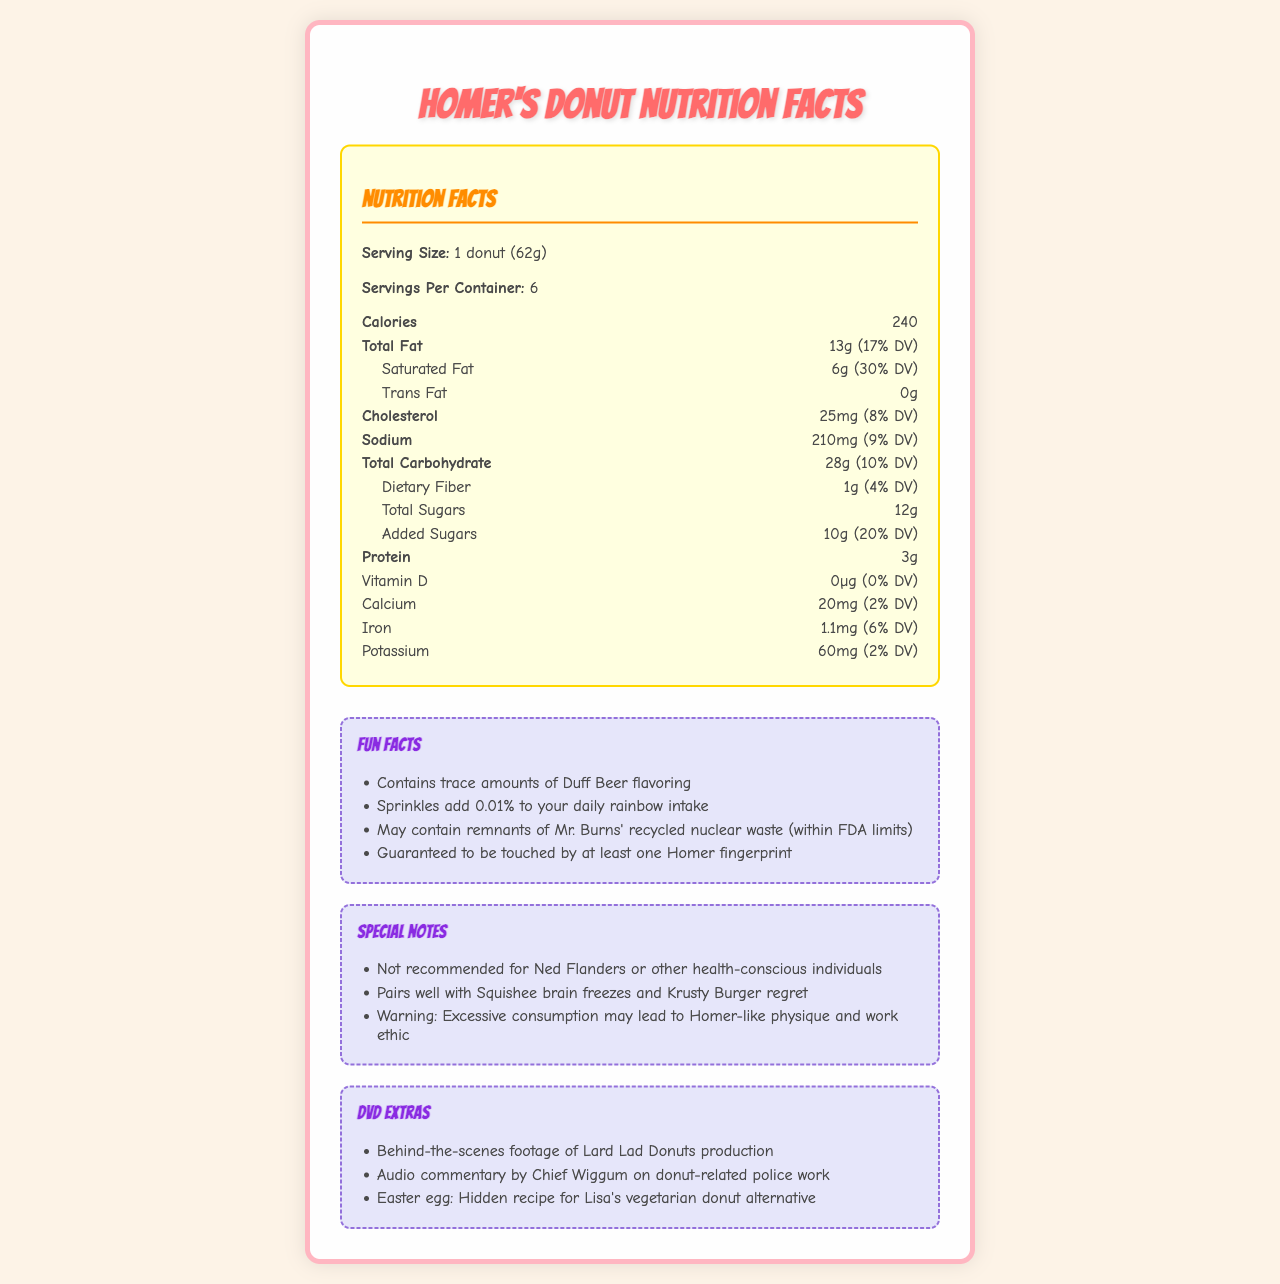what is the daily value percentage of total fat in Homer Simpson's iconic donuts? The 'Total Fat' section mentions that one donut contains 13 grams of fat, which is 17% of the daily value.
Answer: 17% DV what is the daily value percentage of sodium in one donut? The 'Sodium' section lists 210 milligrams of sodium, which is 9% of the daily value.
Answer: 9% DV how much protein is in one serving of the donut? The 'Protein' section states that one donut contains 3 grams of protein.
Answer: 3 grams what are the daily value percentages of Calcium and Iron in one donut? The 'Calcium' section lists 20 milligrams of calcium (2% DV), and the 'Iron' section lists 1.1 milligrams of iron (6% DV).
Answer: Calcium: 2% DV, Iron: 6% DV does the label mention any vitamin D content? The 'Vitamin D' section shows 0 micrograms, which corresponds to 0% of the daily value.
Answer: 0% DV what percentage of your daily value of saturated fat will you consume by eating one donut? The 'Saturated Fat' section lists 6 grams of saturated fat, which is 30% of the daily value.
Answer: 30% DV how much dietary fiber does one donut provide? The 'Dietary Fiber' section lists 1 gram, which is 4% of the daily value.
Answer: 1 gram (4% DV) how many Fun Facts are listed on the label? There are four fun facts listed under the 'Fun Facts' section.
Answer: 4 A single donut contains ___ grams of added sugars. A. 5g B. 10g C. 15g D. 20g The 'Added Sugars' section notes that there are 10 grams of added sugars in one donut.
Answer: B. 10g how many calories are there in one donut? The document lists 240 calories per serving.
Answer: 240 calories what is the daily value percentage of cholesterol in one donut? The 'Cholesterol' section shows 25 milligrams of cholesterol, which is 8% of the daily value.
Answer: 8% DV which of these nutrients is not present in significant amounts in the donuts? A. Vitamin D B. total Sugars C. Sodium D. Iron The 'Vitamin D' section lists 0 micrograms, indicating it is not present in significant amounts.
Answer: A. Vitamin D is the donut recommended for health-conscious individuals like Ned Flanders? The 'Special Notes' section advises against it, specifically mentioning it's not recommended for Ned Flanders or other health-conscious individuals.
Answer: No summarize the main idea of the document. The document is a detailed nutrition label for Homer Simpson's iconic donuts, presenting information about serving size, calories, fat, cholesterol, sodium, carbohydrates, sugars, protein, and other nutrients. Additionally, it features fun facts, special notes advising against consumption for the health-conscious, and DVD extras related to donut production and related humour.
Answer: The document provides nutrition facts for Homer Simpson's iconic donuts, including details about calories, essential nutrients, and daily value percentages. It also includes fun facts, special notes, and DVD extras related to The Simpsons. What ingredient adds a Duff Beer flavor to the donuts? While the fun fact mentions "contains trace amounts of Duff Beer flavoring," it does not specify the exact ingredient responsible for this flavor.
Answer: Cannot be determined 